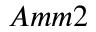<formula> <loc_0><loc_0><loc_500><loc_500>A m m 2</formula> 